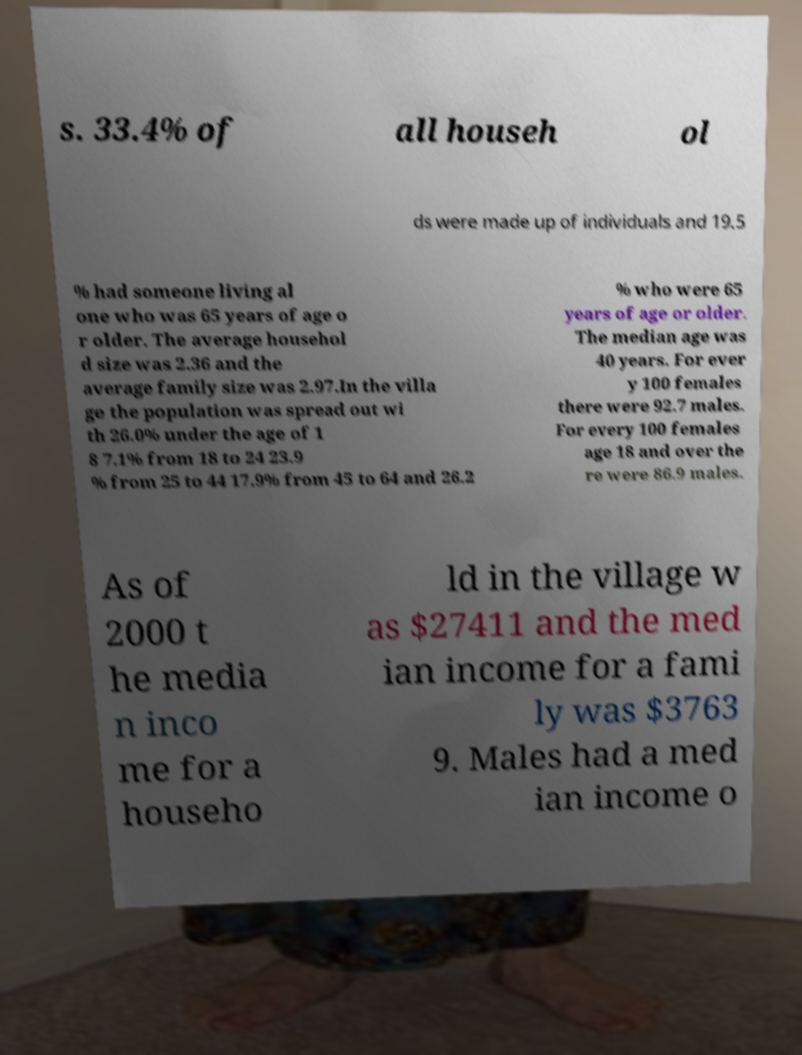Can you read and provide the text displayed in the image?This photo seems to have some interesting text. Can you extract and type it out for me? s. 33.4% of all househ ol ds were made up of individuals and 19.5 % had someone living al one who was 65 years of age o r older. The average househol d size was 2.36 and the average family size was 2.97.In the villa ge the population was spread out wi th 26.0% under the age of 1 8 7.1% from 18 to 24 23.9 % from 25 to 44 17.9% from 45 to 64 and 26.2 % who were 65 years of age or older. The median age was 40 years. For ever y 100 females there were 92.7 males. For every 100 females age 18 and over the re were 86.9 males. As of 2000 t he media n inco me for a househo ld in the village w as $27411 and the med ian income for a fami ly was $3763 9. Males had a med ian income o 